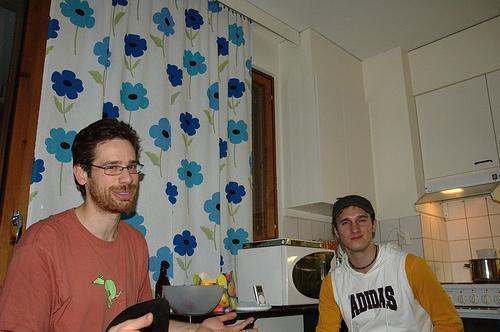How many people are in this picture?
Give a very brief answer. 2. How many are wearing glasses?
Give a very brief answer. 1. 